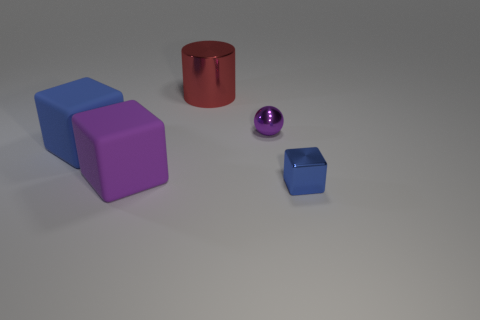Subtract all large rubber cubes. How many cubes are left? 1 Subtract all purple blocks. How many blocks are left? 2 Add 1 big brown shiny things. How many objects exist? 6 Subtract all cubes. How many objects are left? 2 Subtract 3 cubes. How many cubes are left? 0 Subtract all blue balls. How many purple blocks are left? 1 Subtract all small shiny objects. Subtract all big purple rubber blocks. How many objects are left? 2 Add 1 tiny metallic cubes. How many tiny metallic cubes are left? 2 Add 3 small balls. How many small balls exist? 4 Subtract 0 blue balls. How many objects are left? 5 